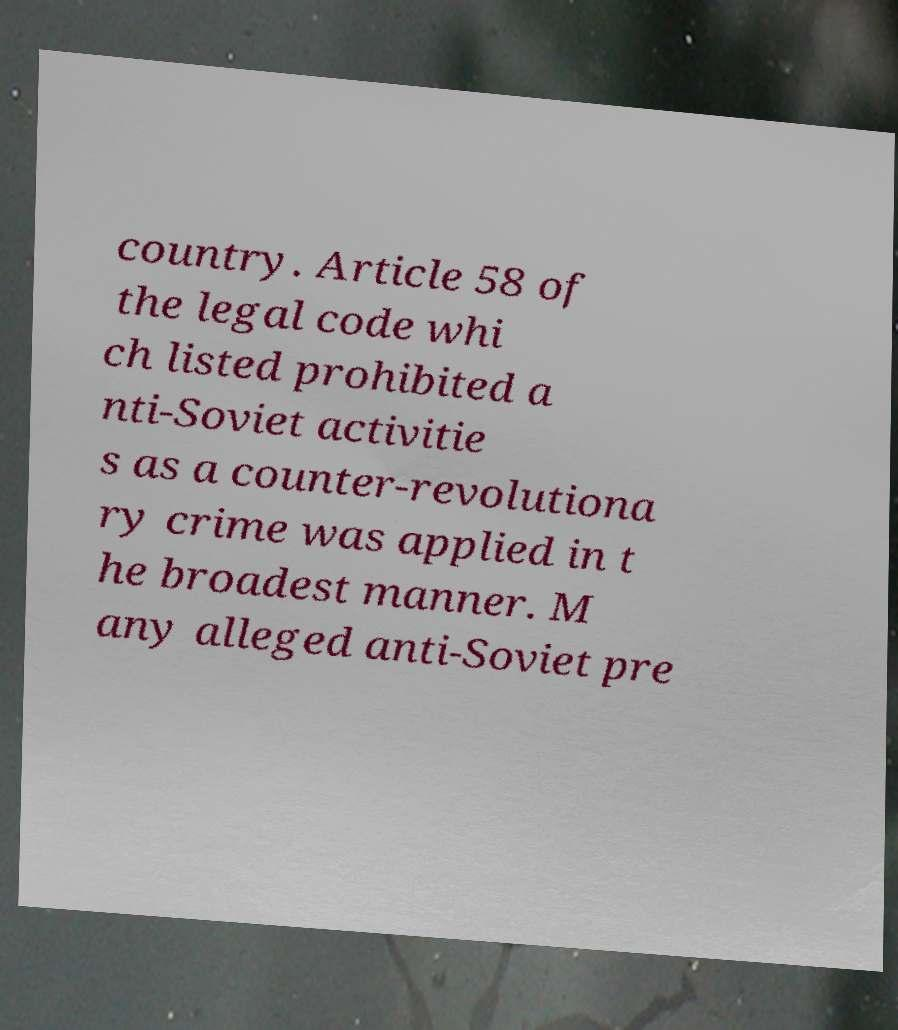Could you assist in decoding the text presented in this image and type it out clearly? country. Article 58 of the legal code whi ch listed prohibited a nti-Soviet activitie s as a counter-revolutiona ry crime was applied in t he broadest manner. M any alleged anti-Soviet pre 